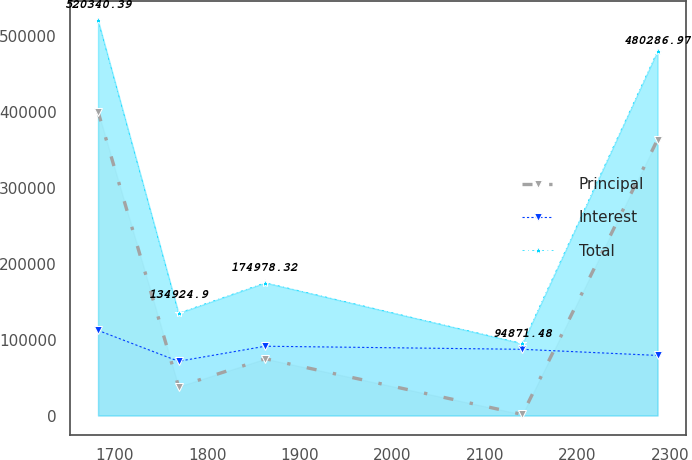Convert chart. <chart><loc_0><loc_0><loc_500><loc_500><line_chart><ecel><fcel>Principal<fcel>Interest<fcel>Total<nl><fcel>1682.07<fcel>400168<fcel>112153<fcel>520340<nl><fcel>1769.12<fcel>38145.9<fcel>71437.7<fcel>134925<nl><fcel>1862.78<fcel>74848.9<fcel>91270.2<fcel>174978<nl><fcel>2140.81<fcel>1442.78<fcel>87198.7<fcel>94871.5<nl><fcel>2286.86<fcel>363465<fcel>79147.4<fcel>480287<nl></chart> 